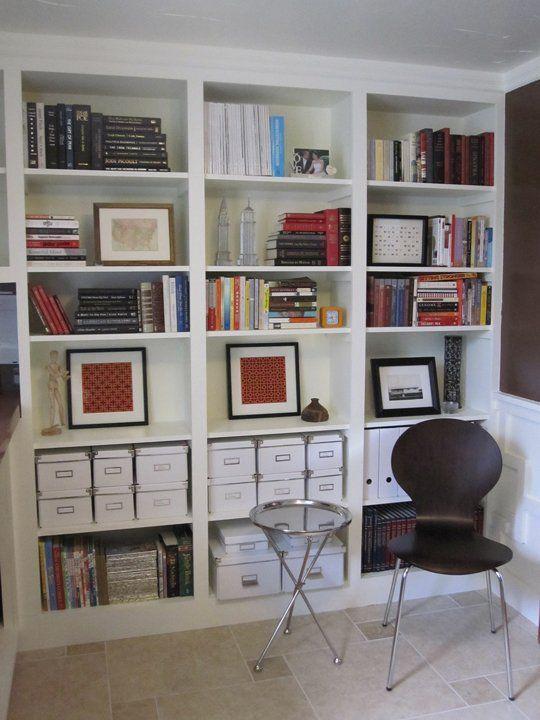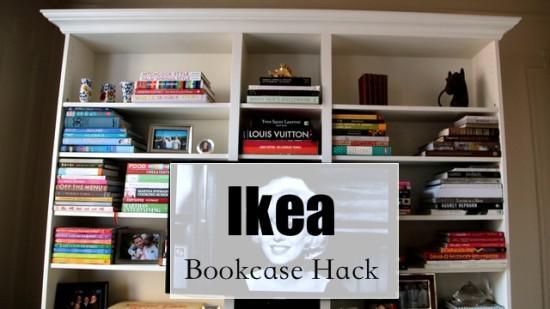The first image is the image on the left, the second image is the image on the right. Given the left and right images, does the statement "The bookshelves in at least one image are flat boards with at least one open end, with items on the shelves serving as bookends." hold true? Answer yes or no. No. The first image is the image on the left, the second image is the image on the right. Given the left and right images, does the statement "Left image shows traditional built-in white bookcase with a white back." hold true? Answer yes or no. Yes. 